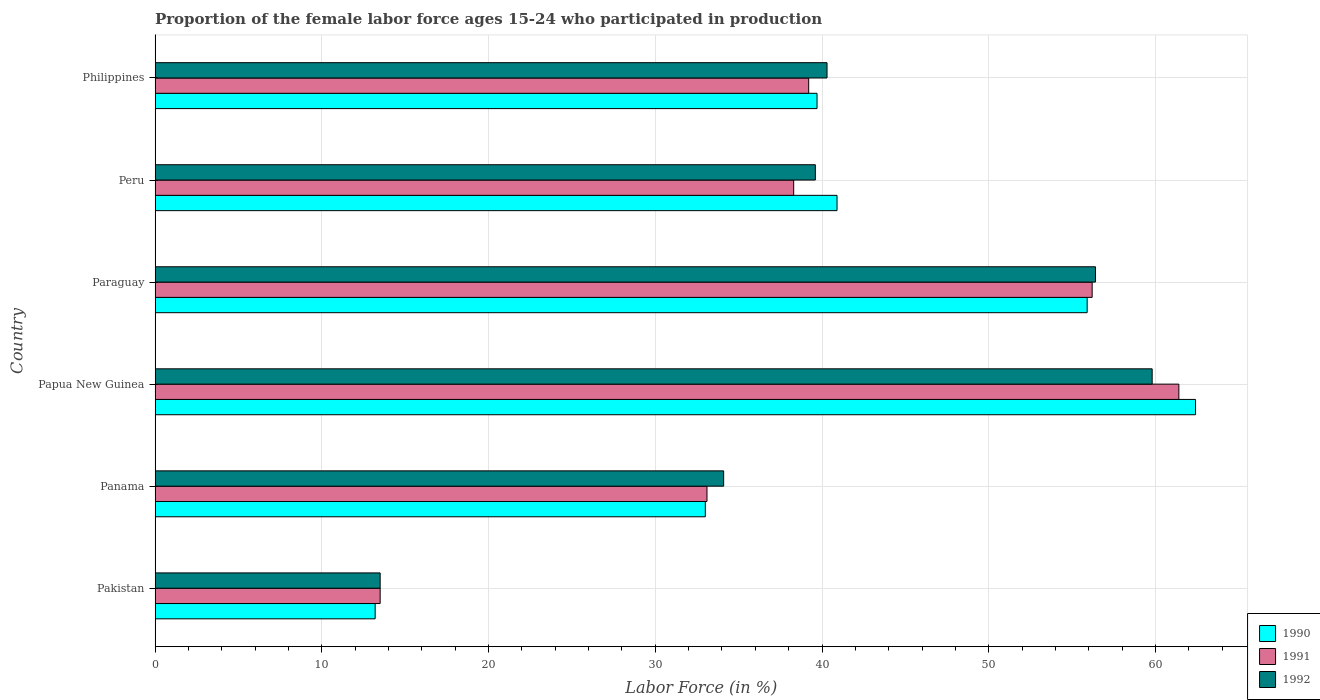Are the number of bars per tick equal to the number of legend labels?
Keep it short and to the point. Yes. How many bars are there on the 2nd tick from the top?
Provide a short and direct response. 3. What is the proportion of the female labor force who participated in production in 1991 in Papua New Guinea?
Your answer should be very brief. 61.4. Across all countries, what is the maximum proportion of the female labor force who participated in production in 1991?
Provide a short and direct response. 61.4. Across all countries, what is the minimum proportion of the female labor force who participated in production in 1991?
Your answer should be compact. 13.5. In which country was the proportion of the female labor force who participated in production in 1992 maximum?
Make the answer very short. Papua New Guinea. What is the total proportion of the female labor force who participated in production in 1992 in the graph?
Give a very brief answer. 243.7. What is the difference between the proportion of the female labor force who participated in production in 1990 in Paraguay and that in Philippines?
Your answer should be very brief. 16.2. What is the difference between the proportion of the female labor force who participated in production in 1992 in Pakistan and the proportion of the female labor force who participated in production in 1991 in Paraguay?
Your answer should be compact. -42.7. What is the average proportion of the female labor force who participated in production in 1990 per country?
Your answer should be very brief. 40.85. What is the difference between the proportion of the female labor force who participated in production in 1992 and proportion of the female labor force who participated in production in 1990 in Peru?
Ensure brevity in your answer.  -1.3. What is the ratio of the proportion of the female labor force who participated in production in 1990 in Panama to that in Papua New Guinea?
Your response must be concise. 0.53. Is the proportion of the female labor force who participated in production in 1991 in Pakistan less than that in Peru?
Your answer should be very brief. Yes. Is the difference between the proportion of the female labor force who participated in production in 1992 in Peru and Philippines greater than the difference between the proportion of the female labor force who participated in production in 1990 in Peru and Philippines?
Keep it short and to the point. No. What is the difference between the highest and the second highest proportion of the female labor force who participated in production in 1991?
Provide a succinct answer. 5.2. What is the difference between the highest and the lowest proportion of the female labor force who participated in production in 1990?
Provide a succinct answer. 49.2. In how many countries, is the proportion of the female labor force who participated in production in 1990 greater than the average proportion of the female labor force who participated in production in 1990 taken over all countries?
Provide a short and direct response. 3. Is the sum of the proportion of the female labor force who participated in production in 1992 in Panama and Papua New Guinea greater than the maximum proportion of the female labor force who participated in production in 1991 across all countries?
Offer a very short reply. Yes. What does the 2nd bar from the bottom in Pakistan represents?
Give a very brief answer. 1991. Is it the case that in every country, the sum of the proportion of the female labor force who participated in production in 1990 and proportion of the female labor force who participated in production in 1991 is greater than the proportion of the female labor force who participated in production in 1992?
Your response must be concise. Yes. How many bars are there?
Ensure brevity in your answer.  18. Are all the bars in the graph horizontal?
Your answer should be very brief. Yes. How many countries are there in the graph?
Provide a succinct answer. 6. Does the graph contain grids?
Provide a short and direct response. Yes. Where does the legend appear in the graph?
Ensure brevity in your answer.  Bottom right. What is the title of the graph?
Make the answer very short. Proportion of the female labor force ages 15-24 who participated in production. Does "1990" appear as one of the legend labels in the graph?
Offer a very short reply. Yes. What is the Labor Force (in %) in 1990 in Pakistan?
Your answer should be very brief. 13.2. What is the Labor Force (in %) in 1991 in Pakistan?
Your response must be concise. 13.5. What is the Labor Force (in %) of 1992 in Pakistan?
Your answer should be compact. 13.5. What is the Labor Force (in %) in 1991 in Panama?
Offer a terse response. 33.1. What is the Labor Force (in %) in 1992 in Panama?
Offer a terse response. 34.1. What is the Labor Force (in %) in 1990 in Papua New Guinea?
Your answer should be compact. 62.4. What is the Labor Force (in %) in 1991 in Papua New Guinea?
Give a very brief answer. 61.4. What is the Labor Force (in %) of 1992 in Papua New Guinea?
Ensure brevity in your answer.  59.8. What is the Labor Force (in %) in 1990 in Paraguay?
Provide a succinct answer. 55.9. What is the Labor Force (in %) of 1991 in Paraguay?
Give a very brief answer. 56.2. What is the Labor Force (in %) in 1992 in Paraguay?
Make the answer very short. 56.4. What is the Labor Force (in %) in 1990 in Peru?
Your response must be concise. 40.9. What is the Labor Force (in %) of 1991 in Peru?
Your answer should be compact. 38.3. What is the Labor Force (in %) of 1992 in Peru?
Make the answer very short. 39.6. What is the Labor Force (in %) in 1990 in Philippines?
Provide a succinct answer. 39.7. What is the Labor Force (in %) in 1991 in Philippines?
Offer a terse response. 39.2. What is the Labor Force (in %) of 1992 in Philippines?
Ensure brevity in your answer.  40.3. Across all countries, what is the maximum Labor Force (in %) of 1990?
Give a very brief answer. 62.4. Across all countries, what is the maximum Labor Force (in %) in 1991?
Give a very brief answer. 61.4. Across all countries, what is the maximum Labor Force (in %) of 1992?
Give a very brief answer. 59.8. Across all countries, what is the minimum Labor Force (in %) of 1990?
Make the answer very short. 13.2. Across all countries, what is the minimum Labor Force (in %) in 1991?
Your answer should be compact. 13.5. Across all countries, what is the minimum Labor Force (in %) of 1992?
Your answer should be compact. 13.5. What is the total Labor Force (in %) of 1990 in the graph?
Offer a terse response. 245.1. What is the total Labor Force (in %) in 1991 in the graph?
Offer a very short reply. 241.7. What is the total Labor Force (in %) in 1992 in the graph?
Provide a succinct answer. 243.7. What is the difference between the Labor Force (in %) of 1990 in Pakistan and that in Panama?
Make the answer very short. -19.8. What is the difference between the Labor Force (in %) in 1991 in Pakistan and that in Panama?
Give a very brief answer. -19.6. What is the difference between the Labor Force (in %) of 1992 in Pakistan and that in Panama?
Give a very brief answer. -20.6. What is the difference between the Labor Force (in %) in 1990 in Pakistan and that in Papua New Guinea?
Give a very brief answer. -49.2. What is the difference between the Labor Force (in %) in 1991 in Pakistan and that in Papua New Guinea?
Offer a terse response. -47.9. What is the difference between the Labor Force (in %) of 1992 in Pakistan and that in Papua New Guinea?
Your answer should be very brief. -46.3. What is the difference between the Labor Force (in %) of 1990 in Pakistan and that in Paraguay?
Ensure brevity in your answer.  -42.7. What is the difference between the Labor Force (in %) of 1991 in Pakistan and that in Paraguay?
Ensure brevity in your answer.  -42.7. What is the difference between the Labor Force (in %) of 1992 in Pakistan and that in Paraguay?
Offer a very short reply. -42.9. What is the difference between the Labor Force (in %) of 1990 in Pakistan and that in Peru?
Your response must be concise. -27.7. What is the difference between the Labor Force (in %) of 1991 in Pakistan and that in Peru?
Your answer should be compact. -24.8. What is the difference between the Labor Force (in %) of 1992 in Pakistan and that in Peru?
Provide a succinct answer. -26.1. What is the difference between the Labor Force (in %) in 1990 in Pakistan and that in Philippines?
Ensure brevity in your answer.  -26.5. What is the difference between the Labor Force (in %) of 1991 in Pakistan and that in Philippines?
Keep it short and to the point. -25.7. What is the difference between the Labor Force (in %) in 1992 in Pakistan and that in Philippines?
Your answer should be very brief. -26.8. What is the difference between the Labor Force (in %) of 1990 in Panama and that in Papua New Guinea?
Offer a very short reply. -29.4. What is the difference between the Labor Force (in %) in 1991 in Panama and that in Papua New Guinea?
Offer a very short reply. -28.3. What is the difference between the Labor Force (in %) in 1992 in Panama and that in Papua New Guinea?
Offer a very short reply. -25.7. What is the difference between the Labor Force (in %) in 1990 in Panama and that in Paraguay?
Make the answer very short. -22.9. What is the difference between the Labor Force (in %) in 1991 in Panama and that in Paraguay?
Offer a terse response. -23.1. What is the difference between the Labor Force (in %) in 1992 in Panama and that in Paraguay?
Make the answer very short. -22.3. What is the difference between the Labor Force (in %) of 1991 in Panama and that in Peru?
Provide a succinct answer. -5.2. What is the difference between the Labor Force (in %) in 1992 in Panama and that in Peru?
Your response must be concise. -5.5. What is the difference between the Labor Force (in %) of 1992 in Panama and that in Philippines?
Keep it short and to the point. -6.2. What is the difference between the Labor Force (in %) of 1990 in Papua New Guinea and that in Peru?
Your answer should be compact. 21.5. What is the difference between the Labor Force (in %) of 1991 in Papua New Guinea and that in Peru?
Your answer should be very brief. 23.1. What is the difference between the Labor Force (in %) of 1992 in Papua New Guinea and that in Peru?
Provide a succinct answer. 20.2. What is the difference between the Labor Force (in %) of 1990 in Papua New Guinea and that in Philippines?
Your answer should be compact. 22.7. What is the difference between the Labor Force (in %) of 1991 in Papua New Guinea and that in Philippines?
Provide a short and direct response. 22.2. What is the difference between the Labor Force (in %) of 1992 in Papua New Guinea and that in Philippines?
Your response must be concise. 19.5. What is the difference between the Labor Force (in %) of 1990 in Paraguay and that in Peru?
Ensure brevity in your answer.  15. What is the difference between the Labor Force (in %) in 1991 in Paraguay and that in Peru?
Your answer should be compact. 17.9. What is the difference between the Labor Force (in %) of 1990 in Paraguay and that in Philippines?
Offer a terse response. 16.2. What is the difference between the Labor Force (in %) in 1991 in Paraguay and that in Philippines?
Your answer should be very brief. 17. What is the difference between the Labor Force (in %) of 1991 in Peru and that in Philippines?
Give a very brief answer. -0.9. What is the difference between the Labor Force (in %) of 1992 in Peru and that in Philippines?
Your answer should be very brief. -0.7. What is the difference between the Labor Force (in %) in 1990 in Pakistan and the Labor Force (in %) in 1991 in Panama?
Keep it short and to the point. -19.9. What is the difference between the Labor Force (in %) in 1990 in Pakistan and the Labor Force (in %) in 1992 in Panama?
Provide a succinct answer. -20.9. What is the difference between the Labor Force (in %) of 1991 in Pakistan and the Labor Force (in %) of 1992 in Panama?
Offer a very short reply. -20.6. What is the difference between the Labor Force (in %) in 1990 in Pakistan and the Labor Force (in %) in 1991 in Papua New Guinea?
Offer a terse response. -48.2. What is the difference between the Labor Force (in %) of 1990 in Pakistan and the Labor Force (in %) of 1992 in Papua New Guinea?
Your answer should be compact. -46.6. What is the difference between the Labor Force (in %) of 1991 in Pakistan and the Labor Force (in %) of 1992 in Papua New Guinea?
Ensure brevity in your answer.  -46.3. What is the difference between the Labor Force (in %) of 1990 in Pakistan and the Labor Force (in %) of 1991 in Paraguay?
Your response must be concise. -43. What is the difference between the Labor Force (in %) in 1990 in Pakistan and the Labor Force (in %) in 1992 in Paraguay?
Your answer should be very brief. -43.2. What is the difference between the Labor Force (in %) in 1991 in Pakistan and the Labor Force (in %) in 1992 in Paraguay?
Offer a terse response. -42.9. What is the difference between the Labor Force (in %) in 1990 in Pakistan and the Labor Force (in %) in 1991 in Peru?
Give a very brief answer. -25.1. What is the difference between the Labor Force (in %) in 1990 in Pakistan and the Labor Force (in %) in 1992 in Peru?
Provide a short and direct response. -26.4. What is the difference between the Labor Force (in %) of 1991 in Pakistan and the Labor Force (in %) of 1992 in Peru?
Make the answer very short. -26.1. What is the difference between the Labor Force (in %) of 1990 in Pakistan and the Labor Force (in %) of 1992 in Philippines?
Offer a very short reply. -27.1. What is the difference between the Labor Force (in %) of 1991 in Pakistan and the Labor Force (in %) of 1992 in Philippines?
Keep it short and to the point. -26.8. What is the difference between the Labor Force (in %) of 1990 in Panama and the Labor Force (in %) of 1991 in Papua New Guinea?
Provide a short and direct response. -28.4. What is the difference between the Labor Force (in %) of 1990 in Panama and the Labor Force (in %) of 1992 in Papua New Guinea?
Keep it short and to the point. -26.8. What is the difference between the Labor Force (in %) of 1991 in Panama and the Labor Force (in %) of 1992 in Papua New Guinea?
Your response must be concise. -26.7. What is the difference between the Labor Force (in %) of 1990 in Panama and the Labor Force (in %) of 1991 in Paraguay?
Offer a very short reply. -23.2. What is the difference between the Labor Force (in %) in 1990 in Panama and the Labor Force (in %) in 1992 in Paraguay?
Your response must be concise. -23.4. What is the difference between the Labor Force (in %) of 1991 in Panama and the Labor Force (in %) of 1992 in Paraguay?
Provide a succinct answer. -23.3. What is the difference between the Labor Force (in %) of 1990 in Panama and the Labor Force (in %) of 1992 in Peru?
Give a very brief answer. -6.6. What is the difference between the Labor Force (in %) of 1990 in Panama and the Labor Force (in %) of 1991 in Philippines?
Offer a terse response. -6.2. What is the difference between the Labor Force (in %) of 1990 in Panama and the Labor Force (in %) of 1992 in Philippines?
Your answer should be compact. -7.3. What is the difference between the Labor Force (in %) in 1990 in Papua New Guinea and the Labor Force (in %) in 1991 in Paraguay?
Keep it short and to the point. 6.2. What is the difference between the Labor Force (in %) in 1990 in Papua New Guinea and the Labor Force (in %) in 1992 in Paraguay?
Offer a terse response. 6. What is the difference between the Labor Force (in %) of 1991 in Papua New Guinea and the Labor Force (in %) of 1992 in Paraguay?
Your answer should be compact. 5. What is the difference between the Labor Force (in %) of 1990 in Papua New Guinea and the Labor Force (in %) of 1991 in Peru?
Your answer should be very brief. 24.1. What is the difference between the Labor Force (in %) of 1990 in Papua New Guinea and the Labor Force (in %) of 1992 in Peru?
Your answer should be compact. 22.8. What is the difference between the Labor Force (in %) of 1991 in Papua New Guinea and the Labor Force (in %) of 1992 in Peru?
Keep it short and to the point. 21.8. What is the difference between the Labor Force (in %) of 1990 in Papua New Guinea and the Labor Force (in %) of 1991 in Philippines?
Your response must be concise. 23.2. What is the difference between the Labor Force (in %) of 1990 in Papua New Guinea and the Labor Force (in %) of 1992 in Philippines?
Make the answer very short. 22.1. What is the difference between the Labor Force (in %) in 1991 in Papua New Guinea and the Labor Force (in %) in 1992 in Philippines?
Make the answer very short. 21.1. What is the difference between the Labor Force (in %) of 1990 in Paraguay and the Labor Force (in %) of 1992 in Philippines?
Keep it short and to the point. 15.6. What is the difference between the Labor Force (in %) of 1990 in Peru and the Labor Force (in %) of 1991 in Philippines?
Keep it short and to the point. 1.7. What is the difference between the Labor Force (in %) in 1991 in Peru and the Labor Force (in %) in 1992 in Philippines?
Offer a terse response. -2. What is the average Labor Force (in %) in 1990 per country?
Your answer should be compact. 40.85. What is the average Labor Force (in %) of 1991 per country?
Your response must be concise. 40.28. What is the average Labor Force (in %) in 1992 per country?
Provide a short and direct response. 40.62. What is the difference between the Labor Force (in %) of 1990 and Labor Force (in %) of 1992 in Pakistan?
Offer a terse response. -0.3. What is the difference between the Labor Force (in %) of 1991 and Labor Force (in %) of 1992 in Pakistan?
Your answer should be compact. 0. What is the difference between the Labor Force (in %) of 1990 and Labor Force (in %) of 1992 in Papua New Guinea?
Make the answer very short. 2.6. What is the difference between the Labor Force (in %) in 1991 and Labor Force (in %) in 1992 in Papua New Guinea?
Give a very brief answer. 1.6. What is the difference between the Labor Force (in %) of 1990 and Labor Force (in %) of 1991 in Paraguay?
Your answer should be compact. -0.3. What is the difference between the Labor Force (in %) in 1990 and Labor Force (in %) in 1992 in Paraguay?
Provide a succinct answer. -0.5. What is the difference between the Labor Force (in %) in 1991 and Labor Force (in %) in 1992 in Paraguay?
Keep it short and to the point. -0.2. What is the difference between the Labor Force (in %) of 1991 and Labor Force (in %) of 1992 in Peru?
Ensure brevity in your answer.  -1.3. What is the difference between the Labor Force (in %) of 1990 and Labor Force (in %) of 1992 in Philippines?
Offer a very short reply. -0.6. What is the difference between the Labor Force (in %) of 1991 and Labor Force (in %) of 1992 in Philippines?
Your answer should be very brief. -1.1. What is the ratio of the Labor Force (in %) in 1991 in Pakistan to that in Panama?
Provide a succinct answer. 0.41. What is the ratio of the Labor Force (in %) in 1992 in Pakistan to that in Panama?
Give a very brief answer. 0.4. What is the ratio of the Labor Force (in %) of 1990 in Pakistan to that in Papua New Guinea?
Give a very brief answer. 0.21. What is the ratio of the Labor Force (in %) in 1991 in Pakistan to that in Papua New Guinea?
Give a very brief answer. 0.22. What is the ratio of the Labor Force (in %) in 1992 in Pakistan to that in Papua New Guinea?
Offer a very short reply. 0.23. What is the ratio of the Labor Force (in %) of 1990 in Pakistan to that in Paraguay?
Your response must be concise. 0.24. What is the ratio of the Labor Force (in %) of 1991 in Pakistan to that in Paraguay?
Ensure brevity in your answer.  0.24. What is the ratio of the Labor Force (in %) in 1992 in Pakistan to that in Paraguay?
Provide a succinct answer. 0.24. What is the ratio of the Labor Force (in %) of 1990 in Pakistan to that in Peru?
Provide a short and direct response. 0.32. What is the ratio of the Labor Force (in %) of 1991 in Pakistan to that in Peru?
Provide a short and direct response. 0.35. What is the ratio of the Labor Force (in %) in 1992 in Pakistan to that in Peru?
Make the answer very short. 0.34. What is the ratio of the Labor Force (in %) of 1990 in Pakistan to that in Philippines?
Offer a very short reply. 0.33. What is the ratio of the Labor Force (in %) of 1991 in Pakistan to that in Philippines?
Provide a succinct answer. 0.34. What is the ratio of the Labor Force (in %) of 1992 in Pakistan to that in Philippines?
Provide a short and direct response. 0.34. What is the ratio of the Labor Force (in %) of 1990 in Panama to that in Papua New Guinea?
Provide a succinct answer. 0.53. What is the ratio of the Labor Force (in %) of 1991 in Panama to that in Papua New Guinea?
Your answer should be compact. 0.54. What is the ratio of the Labor Force (in %) of 1992 in Panama to that in Papua New Guinea?
Keep it short and to the point. 0.57. What is the ratio of the Labor Force (in %) of 1990 in Panama to that in Paraguay?
Provide a succinct answer. 0.59. What is the ratio of the Labor Force (in %) in 1991 in Panama to that in Paraguay?
Your response must be concise. 0.59. What is the ratio of the Labor Force (in %) of 1992 in Panama to that in Paraguay?
Keep it short and to the point. 0.6. What is the ratio of the Labor Force (in %) of 1990 in Panama to that in Peru?
Give a very brief answer. 0.81. What is the ratio of the Labor Force (in %) of 1991 in Panama to that in Peru?
Your answer should be very brief. 0.86. What is the ratio of the Labor Force (in %) in 1992 in Panama to that in Peru?
Your answer should be compact. 0.86. What is the ratio of the Labor Force (in %) of 1990 in Panama to that in Philippines?
Your response must be concise. 0.83. What is the ratio of the Labor Force (in %) of 1991 in Panama to that in Philippines?
Your answer should be very brief. 0.84. What is the ratio of the Labor Force (in %) in 1992 in Panama to that in Philippines?
Your answer should be very brief. 0.85. What is the ratio of the Labor Force (in %) of 1990 in Papua New Guinea to that in Paraguay?
Provide a short and direct response. 1.12. What is the ratio of the Labor Force (in %) of 1991 in Papua New Guinea to that in Paraguay?
Offer a very short reply. 1.09. What is the ratio of the Labor Force (in %) in 1992 in Papua New Guinea to that in Paraguay?
Your answer should be compact. 1.06. What is the ratio of the Labor Force (in %) in 1990 in Papua New Guinea to that in Peru?
Give a very brief answer. 1.53. What is the ratio of the Labor Force (in %) of 1991 in Papua New Guinea to that in Peru?
Keep it short and to the point. 1.6. What is the ratio of the Labor Force (in %) of 1992 in Papua New Guinea to that in Peru?
Your response must be concise. 1.51. What is the ratio of the Labor Force (in %) in 1990 in Papua New Guinea to that in Philippines?
Keep it short and to the point. 1.57. What is the ratio of the Labor Force (in %) of 1991 in Papua New Guinea to that in Philippines?
Make the answer very short. 1.57. What is the ratio of the Labor Force (in %) of 1992 in Papua New Guinea to that in Philippines?
Provide a succinct answer. 1.48. What is the ratio of the Labor Force (in %) in 1990 in Paraguay to that in Peru?
Offer a very short reply. 1.37. What is the ratio of the Labor Force (in %) in 1991 in Paraguay to that in Peru?
Ensure brevity in your answer.  1.47. What is the ratio of the Labor Force (in %) of 1992 in Paraguay to that in Peru?
Your response must be concise. 1.42. What is the ratio of the Labor Force (in %) of 1990 in Paraguay to that in Philippines?
Ensure brevity in your answer.  1.41. What is the ratio of the Labor Force (in %) in 1991 in Paraguay to that in Philippines?
Your answer should be very brief. 1.43. What is the ratio of the Labor Force (in %) in 1992 in Paraguay to that in Philippines?
Provide a succinct answer. 1.4. What is the ratio of the Labor Force (in %) of 1990 in Peru to that in Philippines?
Ensure brevity in your answer.  1.03. What is the ratio of the Labor Force (in %) in 1992 in Peru to that in Philippines?
Provide a succinct answer. 0.98. What is the difference between the highest and the lowest Labor Force (in %) in 1990?
Make the answer very short. 49.2. What is the difference between the highest and the lowest Labor Force (in %) in 1991?
Give a very brief answer. 47.9. What is the difference between the highest and the lowest Labor Force (in %) in 1992?
Provide a short and direct response. 46.3. 